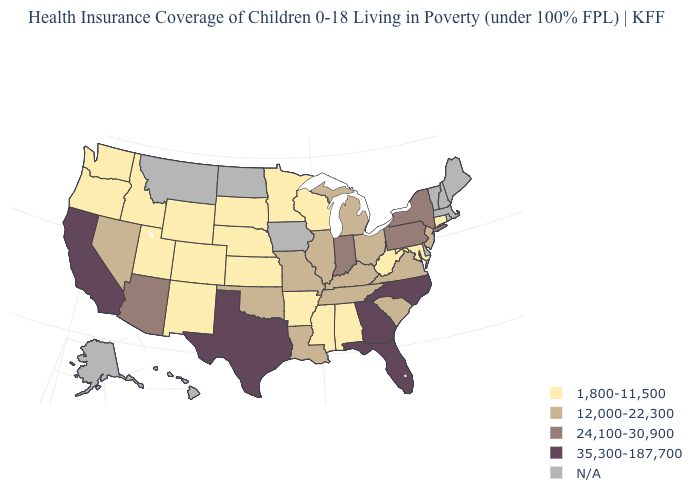Which states have the lowest value in the USA?
Quick response, please. Alabama, Arkansas, Colorado, Connecticut, Idaho, Kansas, Maryland, Minnesota, Mississippi, Nebraska, New Mexico, Oregon, South Dakota, Utah, Washington, West Virginia, Wisconsin, Wyoming. How many symbols are there in the legend?
Give a very brief answer. 5. What is the value of New Hampshire?
Be succinct. N/A. Does the first symbol in the legend represent the smallest category?
Write a very short answer. Yes. Which states hav the highest value in the MidWest?
Concise answer only. Indiana. Among the states that border Maryland , does Pennsylvania have the highest value?
Keep it brief. Yes. What is the lowest value in states that border Georgia?
Give a very brief answer. 1,800-11,500. Name the states that have a value in the range 12,000-22,300?
Be succinct. Illinois, Kentucky, Louisiana, Michigan, Missouri, Nevada, New Jersey, Ohio, Oklahoma, South Carolina, Tennessee, Virginia. What is the highest value in the USA?
Concise answer only. 35,300-187,700. Does Ohio have the lowest value in the USA?
Answer briefly. No. Is the legend a continuous bar?
Write a very short answer. No. What is the lowest value in the USA?
Concise answer only. 1,800-11,500. Name the states that have a value in the range 24,100-30,900?
Write a very short answer. Arizona, Indiana, New York, Pennsylvania. 